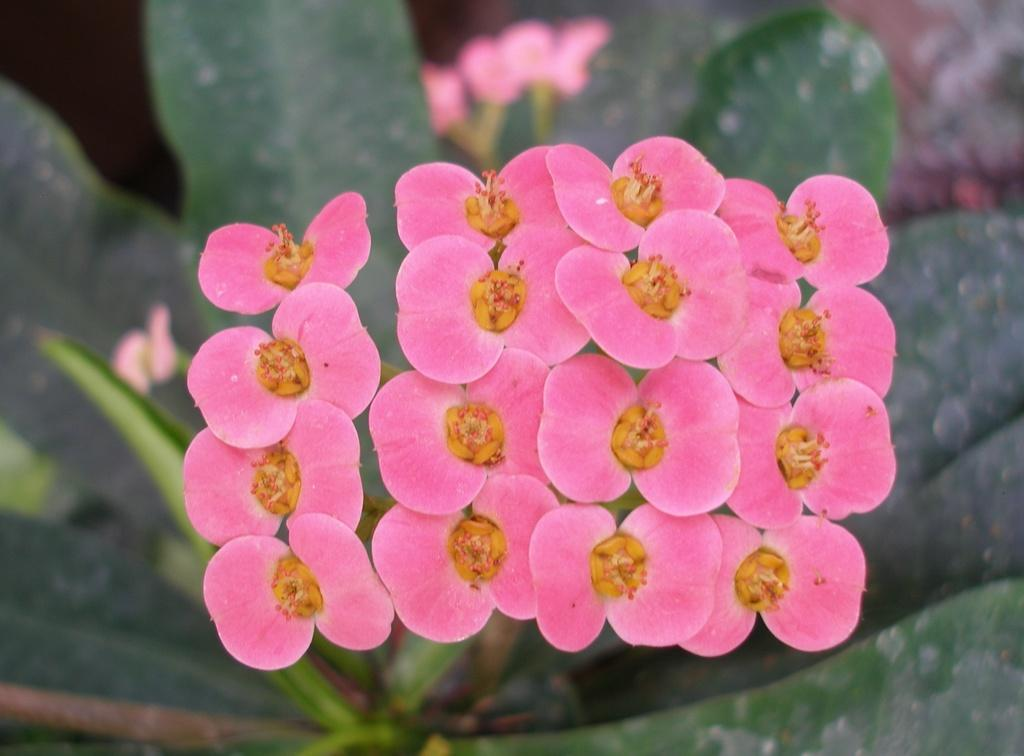What type of plants can be seen in the image? There are flowers in the image. What else can be seen in the background of the image? In the background of the image, there are leaves and other objects. What route does the arch take through the image? There is no arch present in the image. What is the cause of the flowers in the image? The cause of the flowers in the image cannot be determined from the image itself. 